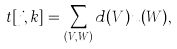<formula> <loc_0><loc_0><loc_500><loc_500>t [ j , k ] = \sum _ { ( V , W ) } d ( V ) u ( W ) ,</formula> 